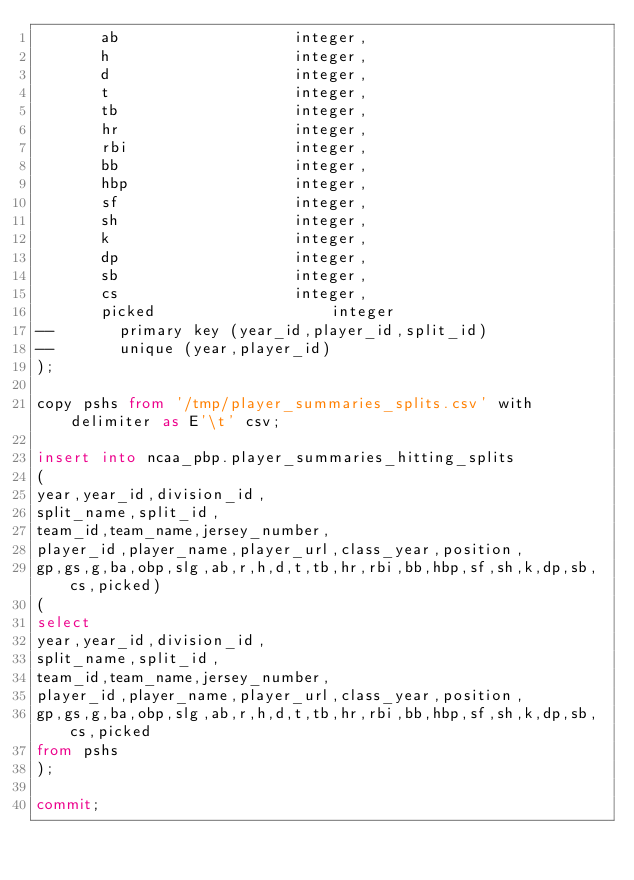Convert code to text. <code><loc_0><loc_0><loc_500><loc_500><_SQL_>       ab					integer,
       h					integer,
       d					integer,
       t					integer,
       tb					integer,
       hr					integer,
       rbi					integer,
       bb					integer,
       hbp					integer,
       sf					integer,
       sh					integer,
       k					integer,
       dp					integer,
       sb					integer,
       cs					integer,
       picked					integer
--       primary key (year_id,player_id,split_id)
--       unique (year,player_id)
);

copy pshs from '/tmp/player_summaries_splits.csv' with delimiter as E'\t' csv;

insert into ncaa_pbp.player_summaries_hitting_splits
(
year,year_id,division_id,
split_name,split_id,
team_id,team_name,jersey_number,
player_id,player_name,player_url,class_year,position,
gp,gs,g,ba,obp,slg,ab,r,h,d,t,tb,hr,rbi,bb,hbp,sf,sh,k,dp,sb,cs,picked)
(
select
year,year_id,division_id,
split_name,split_id,
team_id,team_name,jersey_number,
player_id,player_name,player_url,class_year,position,
gp,gs,g,ba,obp,slg,ab,r,h,d,t,tb,hr,rbi,bb,hbp,sf,sh,k,dp,sb,cs,picked
from pshs
);

commit;
</code> 